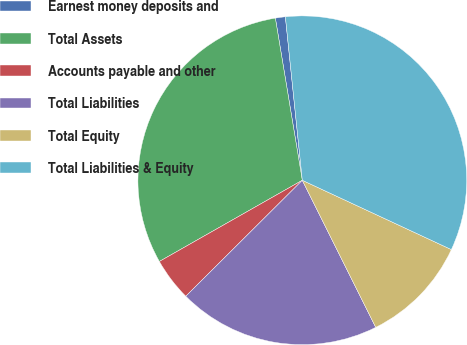<chart> <loc_0><loc_0><loc_500><loc_500><pie_chart><fcel>Earnest money deposits and<fcel>Total Assets<fcel>Accounts payable and other<fcel>Total Liabilities<fcel>Total Equity<fcel>Total Liabilities & Equity<nl><fcel>0.98%<fcel>30.6%<fcel>4.24%<fcel>19.91%<fcel>10.7%<fcel>33.57%<nl></chart> 